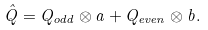<formula> <loc_0><loc_0><loc_500><loc_500>\hat { Q } = Q _ { o d d } \otimes a + Q _ { e v e n } \otimes b .</formula> 